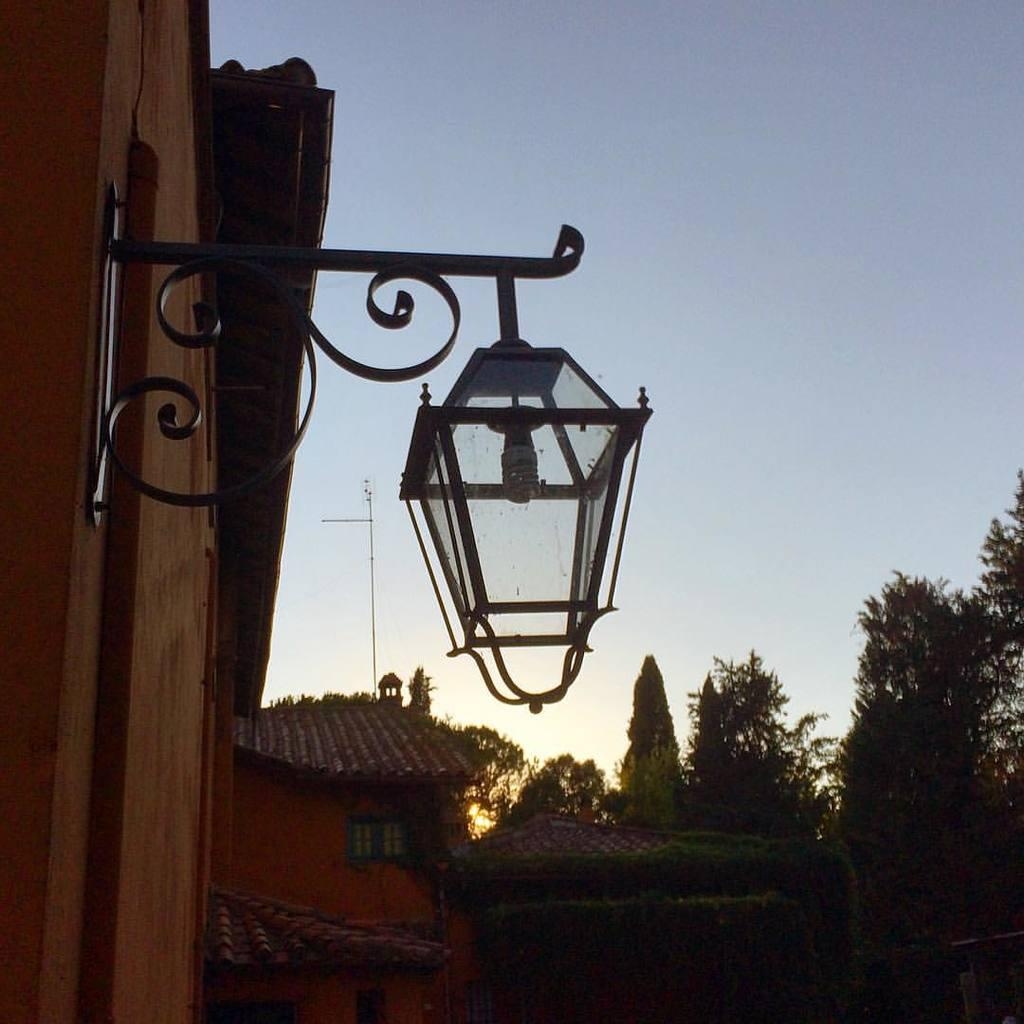What object is located in the middle of the image? There is a lamp in the middle of the image. What type of vegetation is on the right side of the image? There are green trees on the right side of the image. What is visible at the top of the image? The sky is visible at the top of the image. How many elbows can be seen on the trees in the image? There are no elbows present in the image, as trees do not have elbows. Are the brothers playing with the lamp in the image? There is no mention of brothers or any people in the image, so it cannot be determined if they are playing with the lamp. 